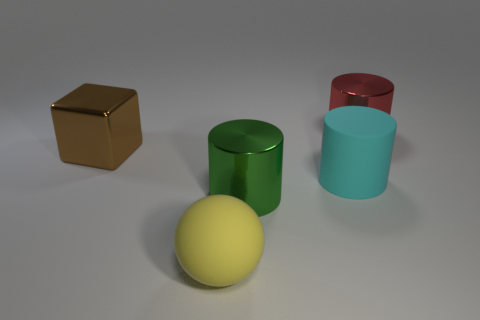Can you describe the colors of the cylinders present in the image? Certainly! There are three cylinders: one is green, another is light blue, and the third one is red. 